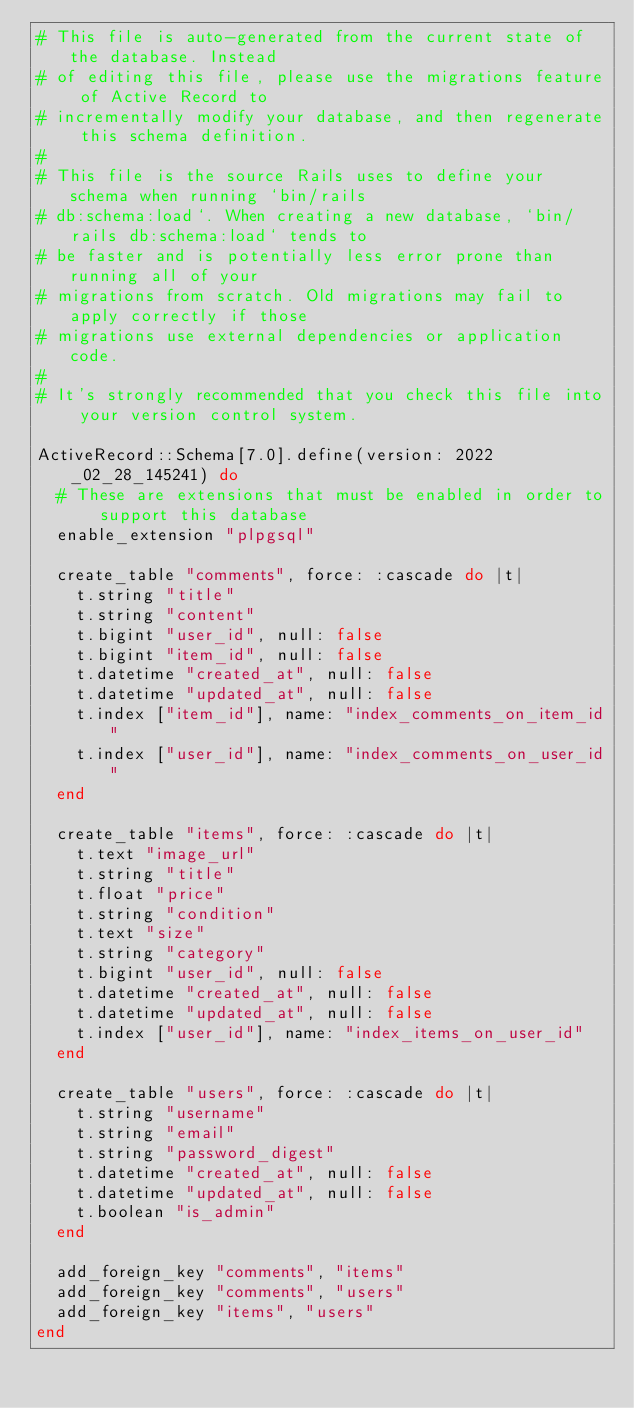Convert code to text. <code><loc_0><loc_0><loc_500><loc_500><_Ruby_># This file is auto-generated from the current state of the database. Instead
# of editing this file, please use the migrations feature of Active Record to
# incrementally modify your database, and then regenerate this schema definition.
#
# This file is the source Rails uses to define your schema when running `bin/rails
# db:schema:load`. When creating a new database, `bin/rails db:schema:load` tends to
# be faster and is potentially less error prone than running all of your
# migrations from scratch. Old migrations may fail to apply correctly if those
# migrations use external dependencies or application code.
#
# It's strongly recommended that you check this file into your version control system.

ActiveRecord::Schema[7.0].define(version: 2022_02_28_145241) do
  # These are extensions that must be enabled in order to support this database
  enable_extension "plpgsql"

  create_table "comments", force: :cascade do |t|
    t.string "title"
    t.string "content"
    t.bigint "user_id", null: false
    t.bigint "item_id", null: false
    t.datetime "created_at", null: false
    t.datetime "updated_at", null: false
    t.index ["item_id"], name: "index_comments_on_item_id"
    t.index ["user_id"], name: "index_comments_on_user_id"
  end

  create_table "items", force: :cascade do |t|
    t.text "image_url"
    t.string "title"
    t.float "price"
    t.string "condition"
    t.text "size"
    t.string "category"
    t.bigint "user_id", null: false
    t.datetime "created_at", null: false
    t.datetime "updated_at", null: false
    t.index ["user_id"], name: "index_items_on_user_id"
  end

  create_table "users", force: :cascade do |t|
    t.string "username"
    t.string "email"
    t.string "password_digest"
    t.datetime "created_at", null: false
    t.datetime "updated_at", null: false
    t.boolean "is_admin"
  end

  add_foreign_key "comments", "items"
  add_foreign_key "comments", "users"
  add_foreign_key "items", "users"
end
</code> 